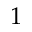<formula> <loc_0><loc_0><loc_500><loc_500>1</formula> 